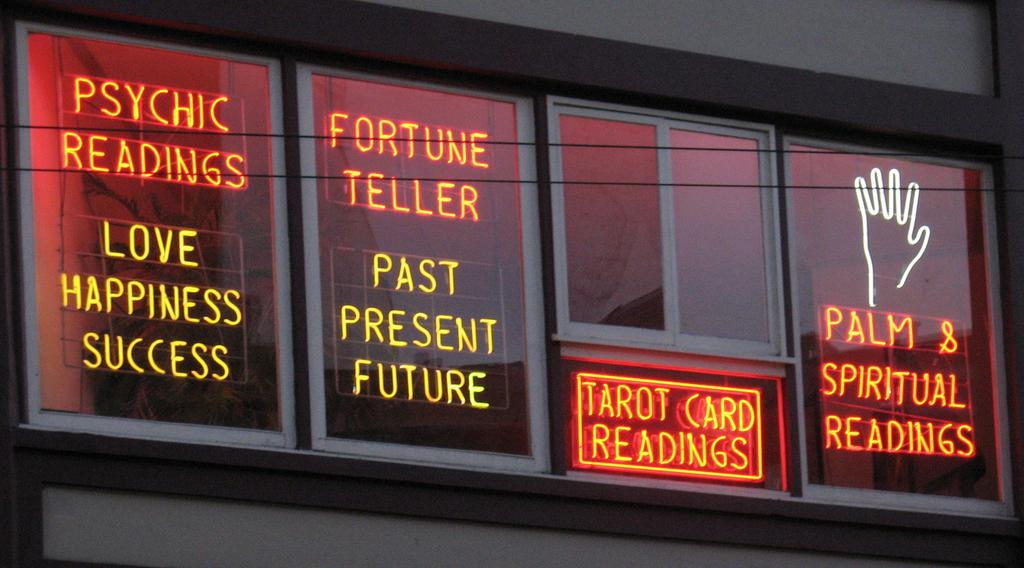<image>
Present a compact description of the photo's key features. A neon sing with several panels advertising various psychic readings and fortune telling. 